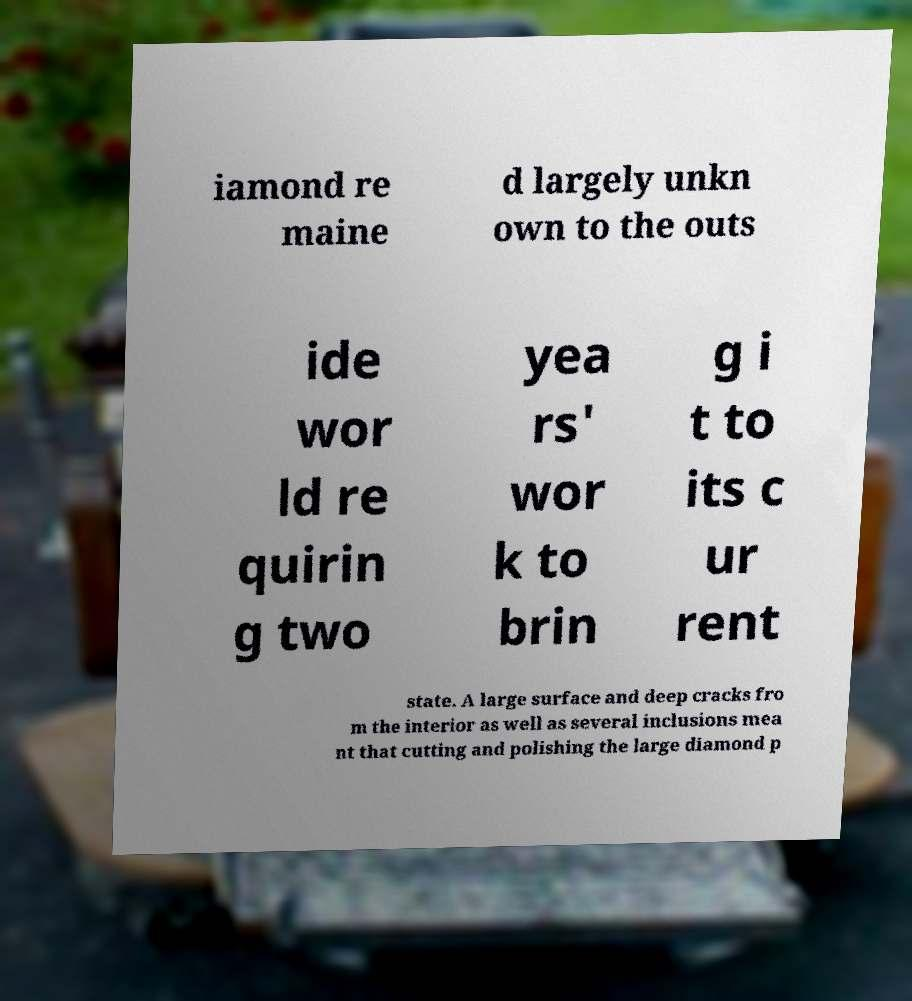I need the written content from this picture converted into text. Can you do that? iamond re maine d largely unkn own to the outs ide wor ld re quirin g two yea rs' wor k to brin g i t to its c ur rent state. A large surface and deep cracks fro m the interior as well as several inclusions mea nt that cutting and polishing the large diamond p 